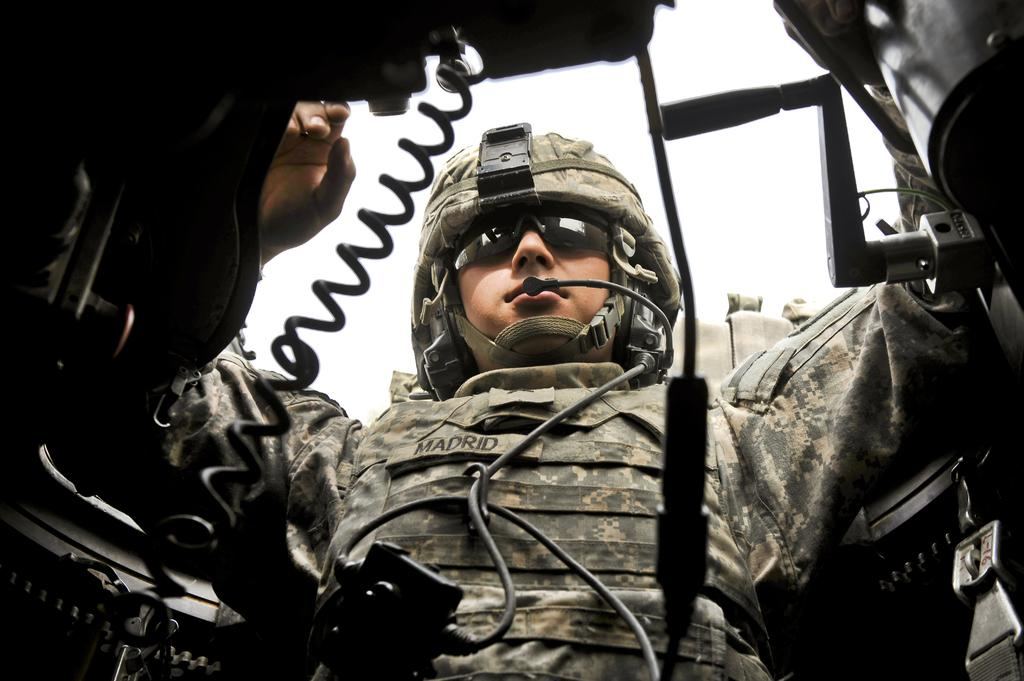What is the person in the image wearing? The person in the image is wearing a uniform, helmet, and goggles. What can be seen in the image besides the person? There are wires and objects visible in the image. What is visible in the background of the image? The sky is visible in the background of the image. Can you tell me how many eggs are in the cellar in the image? There is no mention of eggs or a cellar in the image; the image features a person with a uniform, helmet, goggles, wires, objects, and a visible sky in the background. 